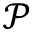<formula> <loc_0><loc_0><loc_500><loc_500>\mathcal { P }</formula> 